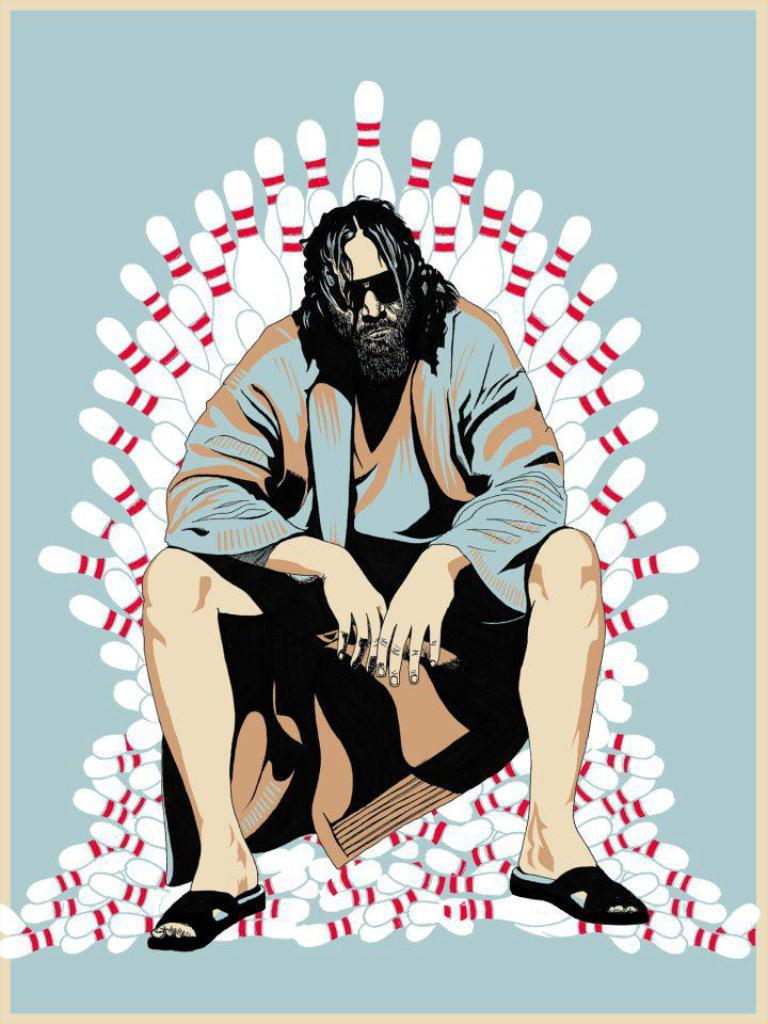What is the person in the image doing? There is a person sitting in the image. What can be seen behind the person? There are bowling pins visible behind the person. Where is the kitty sleeping in the image? There is no kitty present in the image. What type of behavior is the person exhibiting in the image? The provided facts do not give information about the person's behavior, only their position (sitting) and the presence of bowling pins behind them. 